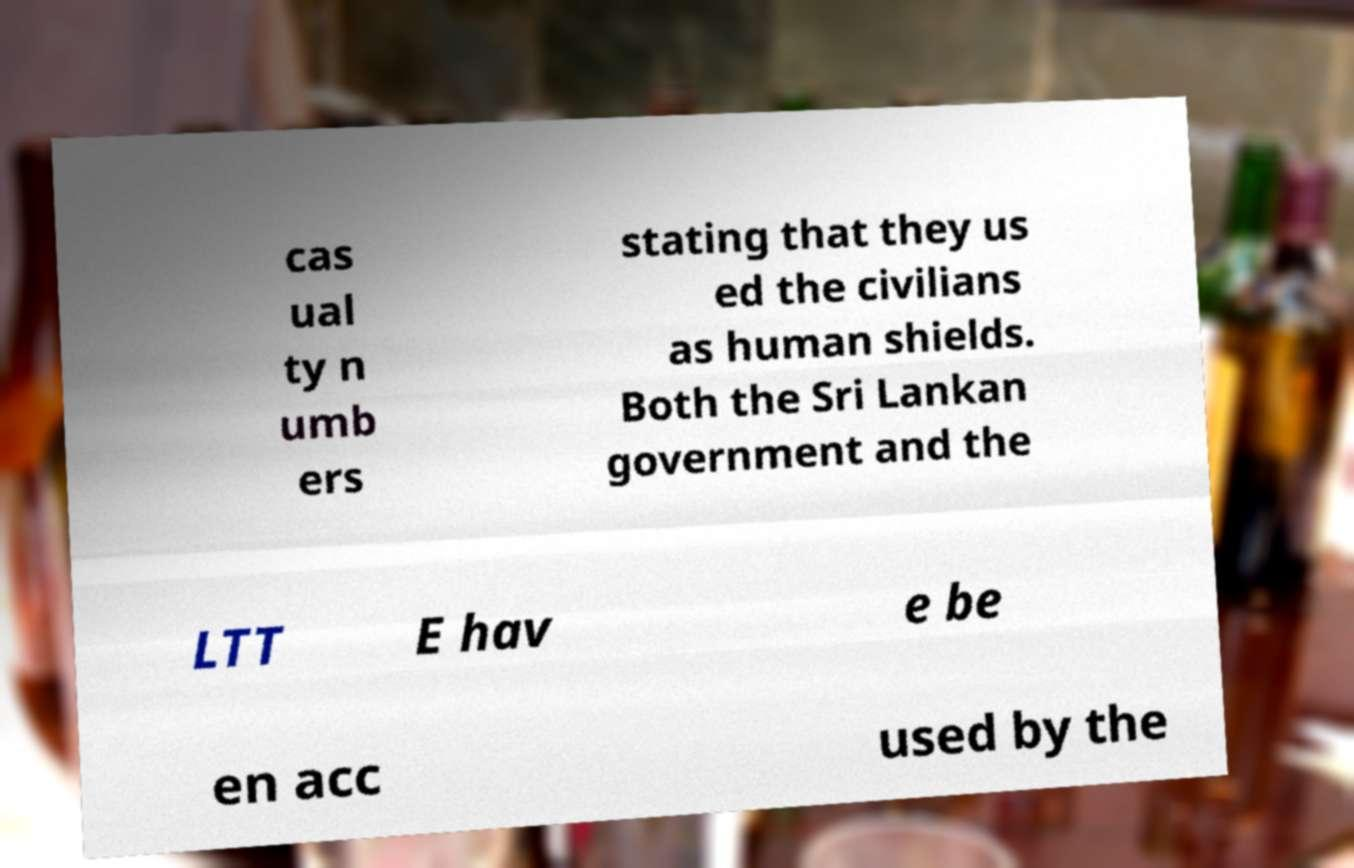Can you accurately transcribe the text from the provided image for me? cas ual ty n umb ers stating that they us ed the civilians as human shields. Both the Sri Lankan government and the LTT E hav e be en acc used by the 